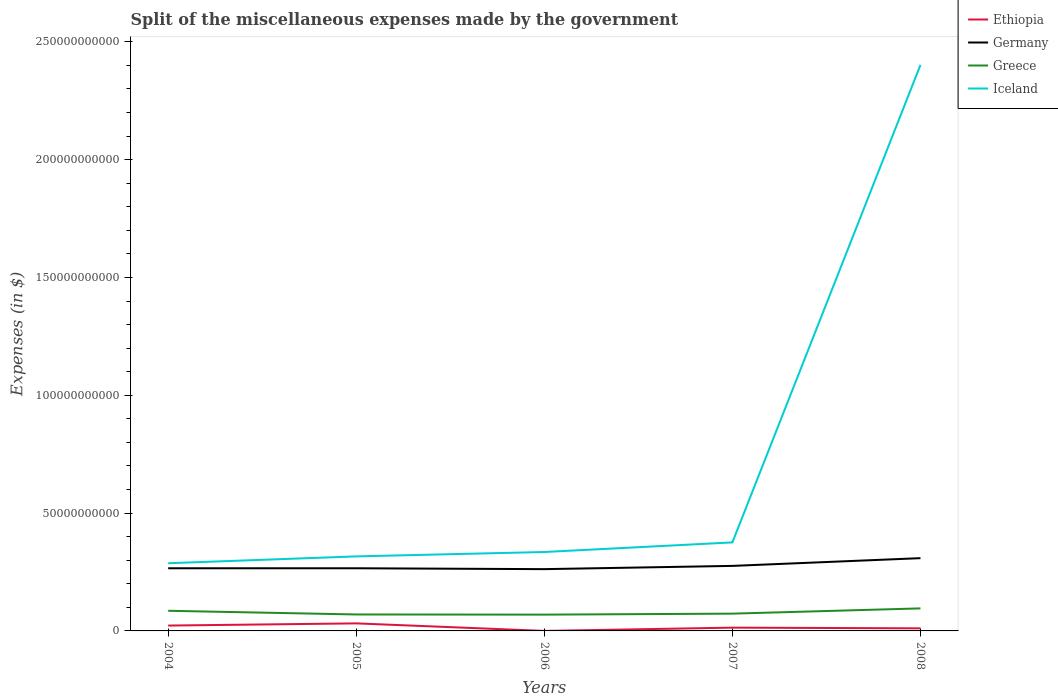Does the line corresponding to Iceland intersect with the line corresponding to Ethiopia?
Your response must be concise. No. Across all years, what is the maximum miscellaneous expenses made by the government in Ethiopia?
Give a very brief answer. 6.20e+06. What is the total miscellaneous expenses made by the government in Greece in the graph?
Ensure brevity in your answer.  -2.58e+09. What is the difference between the highest and the second highest miscellaneous expenses made by the government in Greece?
Offer a very short reply. 2.65e+09. How many lines are there?
Keep it short and to the point. 4. What is the difference between two consecutive major ticks on the Y-axis?
Offer a very short reply. 5.00e+1. Are the values on the major ticks of Y-axis written in scientific E-notation?
Your response must be concise. No. Does the graph contain grids?
Offer a terse response. No. How many legend labels are there?
Your response must be concise. 4. What is the title of the graph?
Your answer should be compact. Split of the miscellaneous expenses made by the government. What is the label or title of the X-axis?
Give a very brief answer. Years. What is the label or title of the Y-axis?
Your response must be concise. Expenses (in $). What is the Expenses (in $) in Ethiopia in 2004?
Provide a short and direct response. 2.27e+09. What is the Expenses (in $) in Germany in 2004?
Make the answer very short. 2.66e+1. What is the Expenses (in $) in Greece in 2004?
Provide a short and direct response. 8.55e+09. What is the Expenses (in $) in Iceland in 2004?
Keep it short and to the point. 2.87e+1. What is the Expenses (in $) of Ethiopia in 2005?
Offer a terse response. 3.20e+09. What is the Expenses (in $) in Germany in 2005?
Give a very brief answer. 2.66e+1. What is the Expenses (in $) of Greece in 2005?
Your answer should be compact. 6.98e+09. What is the Expenses (in $) in Iceland in 2005?
Offer a terse response. 3.16e+1. What is the Expenses (in $) in Ethiopia in 2006?
Your answer should be very brief. 6.20e+06. What is the Expenses (in $) in Germany in 2006?
Your answer should be very brief. 2.62e+1. What is the Expenses (in $) of Greece in 2006?
Give a very brief answer. 6.91e+09. What is the Expenses (in $) of Iceland in 2006?
Your answer should be very brief. 3.35e+1. What is the Expenses (in $) of Ethiopia in 2007?
Your answer should be very brief. 1.39e+09. What is the Expenses (in $) in Germany in 2007?
Provide a short and direct response. 2.76e+1. What is the Expenses (in $) of Greece in 2007?
Ensure brevity in your answer.  7.33e+09. What is the Expenses (in $) of Iceland in 2007?
Ensure brevity in your answer.  3.76e+1. What is the Expenses (in $) in Ethiopia in 2008?
Provide a short and direct response. 1.10e+09. What is the Expenses (in $) in Germany in 2008?
Your answer should be compact. 3.09e+1. What is the Expenses (in $) in Greece in 2008?
Offer a terse response. 9.56e+09. What is the Expenses (in $) in Iceland in 2008?
Your response must be concise. 2.40e+11. Across all years, what is the maximum Expenses (in $) of Ethiopia?
Provide a short and direct response. 3.20e+09. Across all years, what is the maximum Expenses (in $) in Germany?
Give a very brief answer. 3.09e+1. Across all years, what is the maximum Expenses (in $) of Greece?
Make the answer very short. 9.56e+09. Across all years, what is the maximum Expenses (in $) in Iceland?
Provide a short and direct response. 2.40e+11. Across all years, what is the minimum Expenses (in $) of Ethiopia?
Your response must be concise. 6.20e+06. Across all years, what is the minimum Expenses (in $) of Germany?
Give a very brief answer. 2.62e+1. Across all years, what is the minimum Expenses (in $) of Greece?
Offer a very short reply. 6.91e+09. Across all years, what is the minimum Expenses (in $) of Iceland?
Give a very brief answer. 2.87e+1. What is the total Expenses (in $) of Ethiopia in the graph?
Keep it short and to the point. 7.97e+09. What is the total Expenses (in $) of Germany in the graph?
Your answer should be very brief. 1.38e+11. What is the total Expenses (in $) of Greece in the graph?
Provide a short and direct response. 3.93e+1. What is the total Expenses (in $) in Iceland in the graph?
Offer a terse response. 3.72e+11. What is the difference between the Expenses (in $) in Ethiopia in 2004 and that in 2005?
Your answer should be compact. -9.25e+08. What is the difference between the Expenses (in $) of Greece in 2004 and that in 2005?
Give a very brief answer. 1.57e+09. What is the difference between the Expenses (in $) in Iceland in 2004 and that in 2005?
Your answer should be very brief. -2.90e+09. What is the difference between the Expenses (in $) of Ethiopia in 2004 and that in 2006?
Your answer should be very brief. 2.27e+09. What is the difference between the Expenses (in $) of Germany in 2004 and that in 2006?
Your answer should be compact. 3.70e+08. What is the difference between the Expenses (in $) in Greece in 2004 and that in 2006?
Ensure brevity in your answer.  1.64e+09. What is the difference between the Expenses (in $) in Iceland in 2004 and that in 2006?
Make the answer very short. -4.77e+09. What is the difference between the Expenses (in $) of Ethiopia in 2004 and that in 2007?
Your answer should be compact. 8.85e+08. What is the difference between the Expenses (in $) in Germany in 2004 and that in 2007?
Keep it short and to the point. -1.01e+09. What is the difference between the Expenses (in $) in Greece in 2004 and that in 2007?
Make the answer very short. 1.22e+09. What is the difference between the Expenses (in $) in Iceland in 2004 and that in 2007?
Your response must be concise. -8.85e+09. What is the difference between the Expenses (in $) in Ethiopia in 2004 and that in 2008?
Ensure brevity in your answer.  1.17e+09. What is the difference between the Expenses (in $) in Germany in 2004 and that in 2008?
Your response must be concise. -4.29e+09. What is the difference between the Expenses (in $) in Greece in 2004 and that in 2008?
Offer a very short reply. -1.01e+09. What is the difference between the Expenses (in $) in Iceland in 2004 and that in 2008?
Offer a very short reply. -2.11e+11. What is the difference between the Expenses (in $) of Ethiopia in 2005 and that in 2006?
Offer a very short reply. 3.19e+09. What is the difference between the Expenses (in $) of Germany in 2005 and that in 2006?
Give a very brief answer. 3.70e+08. What is the difference between the Expenses (in $) in Greece in 2005 and that in 2006?
Offer a terse response. 7.00e+07. What is the difference between the Expenses (in $) in Iceland in 2005 and that in 2006?
Offer a very short reply. -1.86e+09. What is the difference between the Expenses (in $) of Ethiopia in 2005 and that in 2007?
Ensure brevity in your answer.  1.81e+09. What is the difference between the Expenses (in $) in Germany in 2005 and that in 2007?
Offer a very short reply. -1.01e+09. What is the difference between the Expenses (in $) in Greece in 2005 and that in 2007?
Your response must be concise. -3.48e+08. What is the difference between the Expenses (in $) in Iceland in 2005 and that in 2007?
Ensure brevity in your answer.  -5.94e+09. What is the difference between the Expenses (in $) of Ethiopia in 2005 and that in 2008?
Offer a very short reply. 2.10e+09. What is the difference between the Expenses (in $) in Germany in 2005 and that in 2008?
Offer a very short reply. -4.29e+09. What is the difference between the Expenses (in $) in Greece in 2005 and that in 2008?
Make the answer very short. -2.58e+09. What is the difference between the Expenses (in $) of Iceland in 2005 and that in 2008?
Keep it short and to the point. -2.09e+11. What is the difference between the Expenses (in $) in Ethiopia in 2006 and that in 2007?
Offer a terse response. -1.38e+09. What is the difference between the Expenses (in $) of Germany in 2006 and that in 2007?
Your answer should be very brief. -1.38e+09. What is the difference between the Expenses (in $) of Greece in 2006 and that in 2007?
Provide a succinct answer. -4.18e+08. What is the difference between the Expenses (in $) of Iceland in 2006 and that in 2007?
Give a very brief answer. -4.08e+09. What is the difference between the Expenses (in $) of Ethiopia in 2006 and that in 2008?
Your response must be concise. -1.09e+09. What is the difference between the Expenses (in $) of Germany in 2006 and that in 2008?
Provide a succinct answer. -4.66e+09. What is the difference between the Expenses (in $) in Greece in 2006 and that in 2008?
Offer a terse response. -2.65e+09. What is the difference between the Expenses (in $) in Iceland in 2006 and that in 2008?
Ensure brevity in your answer.  -2.07e+11. What is the difference between the Expenses (in $) in Ethiopia in 2007 and that in 2008?
Make the answer very short. 2.89e+08. What is the difference between the Expenses (in $) in Germany in 2007 and that in 2008?
Provide a succinct answer. -3.28e+09. What is the difference between the Expenses (in $) of Greece in 2007 and that in 2008?
Offer a terse response. -2.23e+09. What is the difference between the Expenses (in $) of Iceland in 2007 and that in 2008?
Offer a terse response. -2.03e+11. What is the difference between the Expenses (in $) in Ethiopia in 2004 and the Expenses (in $) in Germany in 2005?
Give a very brief answer. -2.43e+1. What is the difference between the Expenses (in $) in Ethiopia in 2004 and the Expenses (in $) in Greece in 2005?
Your answer should be very brief. -4.71e+09. What is the difference between the Expenses (in $) of Ethiopia in 2004 and the Expenses (in $) of Iceland in 2005?
Provide a succinct answer. -2.94e+1. What is the difference between the Expenses (in $) in Germany in 2004 and the Expenses (in $) in Greece in 2005?
Offer a very short reply. 1.96e+1. What is the difference between the Expenses (in $) of Germany in 2004 and the Expenses (in $) of Iceland in 2005?
Your answer should be very brief. -5.04e+09. What is the difference between the Expenses (in $) of Greece in 2004 and the Expenses (in $) of Iceland in 2005?
Your answer should be compact. -2.31e+1. What is the difference between the Expenses (in $) in Ethiopia in 2004 and the Expenses (in $) in Germany in 2006?
Give a very brief answer. -2.39e+1. What is the difference between the Expenses (in $) of Ethiopia in 2004 and the Expenses (in $) of Greece in 2006?
Offer a very short reply. -4.64e+09. What is the difference between the Expenses (in $) of Ethiopia in 2004 and the Expenses (in $) of Iceland in 2006?
Your answer should be very brief. -3.12e+1. What is the difference between the Expenses (in $) in Germany in 2004 and the Expenses (in $) in Greece in 2006?
Offer a very short reply. 1.97e+1. What is the difference between the Expenses (in $) in Germany in 2004 and the Expenses (in $) in Iceland in 2006?
Provide a short and direct response. -6.90e+09. What is the difference between the Expenses (in $) in Greece in 2004 and the Expenses (in $) in Iceland in 2006?
Provide a short and direct response. -2.49e+1. What is the difference between the Expenses (in $) of Ethiopia in 2004 and the Expenses (in $) of Germany in 2007?
Provide a succinct answer. -2.53e+1. What is the difference between the Expenses (in $) in Ethiopia in 2004 and the Expenses (in $) in Greece in 2007?
Your answer should be very brief. -5.06e+09. What is the difference between the Expenses (in $) in Ethiopia in 2004 and the Expenses (in $) in Iceland in 2007?
Offer a terse response. -3.53e+1. What is the difference between the Expenses (in $) of Germany in 2004 and the Expenses (in $) of Greece in 2007?
Give a very brief answer. 1.93e+1. What is the difference between the Expenses (in $) in Germany in 2004 and the Expenses (in $) in Iceland in 2007?
Provide a succinct answer. -1.10e+1. What is the difference between the Expenses (in $) in Greece in 2004 and the Expenses (in $) in Iceland in 2007?
Offer a very short reply. -2.90e+1. What is the difference between the Expenses (in $) of Ethiopia in 2004 and the Expenses (in $) of Germany in 2008?
Offer a very short reply. -2.86e+1. What is the difference between the Expenses (in $) in Ethiopia in 2004 and the Expenses (in $) in Greece in 2008?
Offer a very short reply. -7.29e+09. What is the difference between the Expenses (in $) in Ethiopia in 2004 and the Expenses (in $) in Iceland in 2008?
Provide a succinct answer. -2.38e+11. What is the difference between the Expenses (in $) in Germany in 2004 and the Expenses (in $) in Greece in 2008?
Provide a short and direct response. 1.70e+1. What is the difference between the Expenses (in $) of Germany in 2004 and the Expenses (in $) of Iceland in 2008?
Make the answer very short. -2.14e+11. What is the difference between the Expenses (in $) of Greece in 2004 and the Expenses (in $) of Iceland in 2008?
Ensure brevity in your answer.  -2.32e+11. What is the difference between the Expenses (in $) of Ethiopia in 2005 and the Expenses (in $) of Germany in 2006?
Keep it short and to the point. -2.30e+1. What is the difference between the Expenses (in $) in Ethiopia in 2005 and the Expenses (in $) in Greece in 2006?
Offer a very short reply. -3.71e+09. What is the difference between the Expenses (in $) in Ethiopia in 2005 and the Expenses (in $) in Iceland in 2006?
Offer a terse response. -3.03e+1. What is the difference between the Expenses (in $) of Germany in 2005 and the Expenses (in $) of Greece in 2006?
Provide a succinct answer. 1.97e+1. What is the difference between the Expenses (in $) of Germany in 2005 and the Expenses (in $) of Iceland in 2006?
Your response must be concise. -6.90e+09. What is the difference between the Expenses (in $) in Greece in 2005 and the Expenses (in $) in Iceland in 2006?
Keep it short and to the point. -2.65e+1. What is the difference between the Expenses (in $) in Ethiopia in 2005 and the Expenses (in $) in Germany in 2007?
Give a very brief answer. -2.44e+1. What is the difference between the Expenses (in $) in Ethiopia in 2005 and the Expenses (in $) in Greece in 2007?
Keep it short and to the point. -4.13e+09. What is the difference between the Expenses (in $) in Ethiopia in 2005 and the Expenses (in $) in Iceland in 2007?
Your answer should be very brief. -3.44e+1. What is the difference between the Expenses (in $) of Germany in 2005 and the Expenses (in $) of Greece in 2007?
Provide a succinct answer. 1.93e+1. What is the difference between the Expenses (in $) in Germany in 2005 and the Expenses (in $) in Iceland in 2007?
Ensure brevity in your answer.  -1.10e+1. What is the difference between the Expenses (in $) in Greece in 2005 and the Expenses (in $) in Iceland in 2007?
Provide a short and direct response. -3.06e+1. What is the difference between the Expenses (in $) of Ethiopia in 2005 and the Expenses (in $) of Germany in 2008?
Your answer should be very brief. -2.77e+1. What is the difference between the Expenses (in $) in Ethiopia in 2005 and the Expenses (in $) in Greece in 2008?
Your answer should be very brief. -6.36e+09. What is the difference between the Expenses (in $) of Ethiopia in 2005 and the Expenses (in $) of Iceland in 2008?
Offer a terse response. -2.37e+11. What is the difference between the Expenses (in $) of Germany in 2005 and the Expenses (in $) of Greece in 2008?
Ensure brevity in your answer.  1.70e+1. What is the difference between the Expenses (in $) in Germany in 2005 and the Expenses (in $) in Iceland in 2008?
Provide a short and direct response. -2.14e+11. What is the difference between the Expenses (in $) of Greece in 2005 and the Expenses (in $) of Iceland in 2008?
Ensure brevity in your answer.  -2.33e+11. What is the difference between the Expenses (in $) in Ethiopia in 2006 and the Expenses (in $) in Germany in 2007?
Your answer should be compact. -2.76e+1. What is the difference between the Expenses (in $) in Ethiopia in 2006 and the Expenses (in $) in Greece in 2007?
Ensure brevity in your answer.  -7.33e+09. What is the difference between the Expenses (in $) in Ethiopia in 2006 and the Expenses (in $) in Iceland in 2007?
Keep it short and to the point. -3.76e+1. What is the difference between the Expenses (in $) in Germany in 2006 and the Expenses (in $) in Greece in 2007?
Give a very brief answer. 1.89e+1. What is the difference between the Expenses (in $) of Germany in 2006 and the Expenses (in $) of Iceland in 2007?
Provide a short and direct response. -1.14e+1. What is the difference between the Expenses (in $) of Greece in 2006 and the Expenses (in $) of Iceland in 2007?
Keep it short and to the point. -3.07e+1. What is the difference between the Expenses (in $) in Ethiopia in 2006 and the Expenses (in $) in Germany in 2008?
Your answer should be very brief. -3.09e+1. What is the difference between the Expenses (in $) in Ethiopia in 2006 and the Expenses (in $) in Greece in 2008?
Your answer should be compact. -9.56e+09. What is the difference between the Expenses (in $) in Ethiopia in 2006 and the Expenses (in $) in Iceland in 2008?
Provide a succinct answer. -2.40e+11. What is the difference between the Expenses (in $) of Germany in 2006 and the Expenses (in $) of Greece in 2008?
Your answer should be very brief. 1.67e+1. What is the difference between the Expenses (in $) of Germany in 2006 and the Expenses (in $) of Iceland in 2008?
Keep it short and to the point. -2.14e+11. What is the difference between the Expenses (in $) of Greece in 2006 and the Expenses (in $) of Iceland in 2008?
Provide a short and direct response. -2.33e+11. What is the difference between the Expenses (in $) of Ethiopia in 2007 and the Expenses (in $) of Germany in 2008?
Make the answer very short. -2.95e+1. What is the difference between the Expenses (in $) of Ethiopia in 2007 and the Expenses (in $) of Greece in 2008?
Offer a terse response. -8.17e+09. What is the difference between the Expenses (in $) of Ethiopia in 2007 and the Expenses (in $) of Iceland in 2008?
Make the answer very short. -2.39e+11. What is the difference between the Expenses (in $) of Germany in 2007 and the Expenses (in $) of Greece in 2008?
Offer a terse response. 1.80e+1. What is the difference between the Expenses (in $) in Germany in 2007 and the Expenses (in $) in Iceland in 2008?
Offer a very short reply. -2.13e+11. What is the difference between the Expenses (in $) in Greece in 2007 and the Expenses (in $) in Iceland in 2008?
Offer a very short reply. -2.33e+11. What is the average Expenses (in $) of Ethiopia per year?
Make the answer very short. 1.59e+09. What is the average Expenses (in $) in Germany per year?
Provide a short and direct response. 2.76e+1. What is the average Expenses (in $) in Greece per year?
Ensure brevity in your answer.  7.87e+09. What is the average Expenses (in $) in Iceland per year?
Your answer should be compact. 7.43e+1. In the year 2004, what is the difference between the Expenses (in $) of Ethiopia and Expenses (in $) of Germany?
Keep it short and to the point. -2.43e+1. In the year 2004, what is the difference between the Expenses (in $) of Ethiopia and Expenses (in $) of Greece?
Keep it short and to the point. -6.28e+09. In the year 2004, what is the difference between the Expenses (in $) of Ethiopia and Expenses (in $) of Iceland?
Offer a very short reply. -2.65e+1. In the year 2004, what is the difference between the Expenses (in $) of Germany and Expenses (in $) of Greece?
Your answer should be very brief. 1.80e+1. In the year 2004, what is the difference between the Expenses (in $) of Germany and Expenses (in $) of Iceland?
Your answer should be very brief. -2.13e+09. In the year 2004, what is the difference between the Expenses (in $) in Greece and Expenses (in $) in Iceland?
Your answer should be very brief. -2.02e+1. In the year 2005, what is the difference between the Expenses (in $) in Ethiopia and Expenses (in $) in Germany?
Offer a very short reply. -2.34e+1. In the year 2005, what is the difference between the Expenses (in $) in Ethiopia and Expenses (in $) in Greece?
Provide a succinct answer. -3.78e+09. In the year 2005, what is the difference between the Expenses (in $) in Ethiopia and Expenses (in $) in Iceland?
Offer a terse response. -2.84e+1. In the year 2005, what is the difference between the Expenses (in $) in Germany and Expenses (in $) in Greece?
Offer a very short reply. 1.96e+1. In the year 2005, what is the difference between the Expenses (in $) of Germany and Expenses (in $) of Iceland?
Provide a short and direct response. -5.04e+09. In the year 2005, what is the difference between the Expenses (in $) in Greece and Expenses (in $) in Iceland?
Offer a very short reply. -2.46e+1. In the year 2006, what is the difference between the Expenses (in $) in Ethiopia and Expenses (in $) in Germany?
Give a very brief answer. -2.62e+1. In the year 2006, what is the difference between the Expenses (in $) in Ethiopia and Expenses (in $) in Greece?
Offer a terse response. -6.91e+09. In the year 2006, what is the difference between the Expenses (in $) of Ethiopia and Expenses (in $) of Iceland?
Make the answer very short. -3.35e+1. In the year 2006, what is the difference between the Expenses (in $) in Germany and Expenses (in $) in Greece?
Keep it short and to the point. 1.93e+1. In the year 2006, what is the difference between the Expenses (in $) of Germany and Expenses (in $) of Iceland?
Keep it short and to the point. -7.27e+09. In the year 2006, what is the difference between the Expenses (in $) of Greece and Expenses (in $) of Iceland?
Offer a terse response. -2.66e+1. In the year 2007, what is the difference between the Expenses (in $) of Ethiopia and Expenses (in $) of Germany?
Make the answer very short. -2.62e+1. In the year 2007, what is the difference between the Expenses (in $) of Ethiopia and Expenses (in $) of Greece?
Make the answer very short. -5.94e+09. In the year 2007, what is the difference between the Expenses (in $) in Ethiopia and Expenses (in $) in Iceland?
Your answer should be very brief. -3.62e+1. In the year 2007, what is the difference between the Expenses (in $) of Germany and Expenses (in $) of Greece?
Provide a short and direct response. 2.03e+1. In the year 2007, what is the difference between the Expenses (in $) of Germany and Expenses (in $) of Iceland?
Keep it short and to the point. -9.97e+09. In the year 2007, what is the difference between the Expenses (in $) in Greece and Expenses (in $) in Iceland?
Provide a succinct answer. -3.02e+1. In the year 2008, what is the difference between the Expenses (in $) of Ethiopia and Expenses (in $) of Germany?
Give a very brief answer. -2.98e+1. In the year 2008, what is the difference between the Expenses (in $) of Ethiopia and Expenses (in $) of Greece?
Your answer should be very brief. -8.46e+09. In the year 2008, what is the difference between the Expenses (in $) of Ethiopia and Expenses (in $) of Iceland?
Provide a succinct answer. -2.39e+11. In the year 2008, what is the difference between the Expenses (in $) in Germany and Expenses (in $) in Greece?
Ensure brevity in your answer.  2.13e+1. In the year 2008, what is the difference between the Expenses (in $) in Germany and Expenses (in $) in Iceland?
Keep it short and to the point. -2.09e+11. In the year 2008, what is the difference between the Expenses (in $) of Greece and Expenses (in $) of Iceland?
Offer a very short reply. -2.31e+11. What is the ratio of the Expenses (in $) of Ethiopia in 2004 to that in 2005?
Offer a terse response. 0.71. What is the ratio of the Expenses (in $) in Greece in 2004 to that in 2005?
Give a very brief answer. 1.22. What is the ratio of the Expenses (in $) of Iceland in 2004 to that in 2005?
Make the answer very short. 0.91. What is the ratio of the Expenses (in $) of Ethiopia in 2004 to that in 2006?
Provide a short and direct response. 366.84. What is the ratio of the Expenses (in $) of Germany in 2004 to that in 2006?
Your response must be concise. 1.01. What is the ratio of the Expenses (in $) in Greece in 2004 to that in 2006?
Offer a very short reply. 1.24. What is the ratio of the Expenses (in $) of Iceland in 2004 to that in 2006?
Ensure brevity in your answer.  0.86. What is the ratio of the Expenses (in $) in Ethiopia in 2004 to that in 2007?
Make the answer very short. 1.64. What is the ratio of the Expenses (in $) in Germany in 2004 to that in 2007?
Ensure brevity in your answer.  0.96. What is the ratio of the Expenses (in $) in Greece in 2004 to that in 2007?
Make the answer very short. 1.17. What is the ratio of the Expenses (in $) in Iceland in 2004 to that in 2007?
Provide a short and direct response. 0.76. What is the ratio of the Expenses (in $) of Ethiopia in 2004 to that in 2008?
Your answer should be very brief. 2.07. What is the ratio of the Expenses (in $) in Germany in 2004 to that in 2008?
Ensure brevity in your answer.  0.86. What is the ratio of the Expenses (in $) of Greece in 2004 to that in 2008?
Give a very brief answer. 0.89. What is the ratio of the Expenses (in $) in Iceland in 2004 to that in 2008?
Your answer should be very brief. 0.12. What is the ratio of the Expenses (in $) of Ethiopia in 2005 to that in 2006?
Give a very brief answer. 516.06. What is the ratio of the Expenses (in $) in Germany in 2005 to that in 2006?
Keep it short and to the point. 1.01. What is the ratio of the Expenses (in $) of Greece in 2005 to that in 2006?
Your answer should be compact. 1.01. What is the ratio of the Expenses (in $) in Iceland in 2005 to that in 2006?
Provide a short and direct response. 0.94. What is the ratio of the Expenses (in $) of Ethiopia in 2005 to that in 2007?
Offer a very short reply. 2.3. What is the ratio of the Expenses (in $) of Germany in 2005 to that in 2007?
Provide a succinct answer. 0.96. What is the ratio of the Expenses (in $) of Greece in 2005 to that in 2007?
Your response must be concise. 0.95. What is the ratio of the Expenses (in $) in Iceland in 2005 to that in 2007?
Your response must be concise. 0.84. What is the ratio of the Expenses (in $) of Ethiopia in 2005 to that in 2008?
Your answer should be very brief. 2.91. What is the ratio of the Expenses (in $) in Germany in 2005 to that in 2008?
Your response must be concise. 0.86. What is the ratio of the Expenses (in $) of Greece in 2005 to that in 2008?
Make the answer very short. 0.73. What is the ratio of the Expenses (in $) in Iceland in 2005 to that in 2008?
Your answer should be very brief. 0.13. What is the ratio of the Expenses (in $) of Ethiopia in 2006 to that in 2007?
Keep it short and to the point. 0. What is the ratio of the Expenses (in $) of Germany in 2006 to that in 2007?
Keep it short and to the point. 0.95. What is the ratio of the Expenses (in $) of Greece in 2006 to that in 2007?
Provide a short and direct response. 0.94. What is the ratio of the Expenses (in $) in Iceland in 2006 to that in 2007?
Offer a very short reply. 0.89. What is the ratio of the Expenses (in $) in Ethiopia in 2006 to that in 2008?
Offer a terse response. 0.01. What is the ratio of the Expenses (in $) of Germany in 2006 to that in 2008?
Ensure brevity in your answer.  0.85. What is the ratio of the Expenses (in $) in Greece in 2006 to that in 2008?
Give a very brief answer. 0.72. What is the ratio of the Expenses (in $) in Iceland in 2006 to that in 2008?
Your answer should be very brief. 0.14. What is the ratio of the Expenses (in $) in Ethiopia in 2007 to that in 2008?
Your response must be concise. 1.26. What is the ratio of the Expenses (in $) in Germany in 2007 to that in 2008?
Your response must be concise. 0.89. What is the ratio of the Expenses (in $) of Greece in 2007 to that in 2008?
Provide a short and direct response. 0.77. What is the ratio of the Expenses (in $) of Iceland in 2007 to that in 2008?
Give a very brief answer. 0.16. What is the difference between the highest and the second highest Expenses (in $) of Ethiopia?
Your answer should be very brief. 9.25e+08. What is the difference between the highest and the second highest Expenses (in $) in Germany?
Make the answer very short. 3.28e+09. What is the difference between the highest and the second highest Expenses (in $) in Greece?
Keep it short and to the point. 1.01e+09. What is the difference between the highest and the second highest Expenses (in $) in Iceland?
Ensure brevity in your answer.  2.03e+11. What is the difference between the highest and the lowest Expenses (in $) in Ethiopia?
Your answer should be very brief. 3.19e+09. What is the difference between the highest and the lowest Expenses (in $) in Germany?
Give a very brief answer. 4.66e+09. What is the difference between the highest and the lowest Expenses (in $) of Greece?
Keep it short and to the point. 2.65e+09. What is the difference between the highest and the lowest Expenses (in $) in Iceland?
Keep it short and to the point. 2.11e+11. 